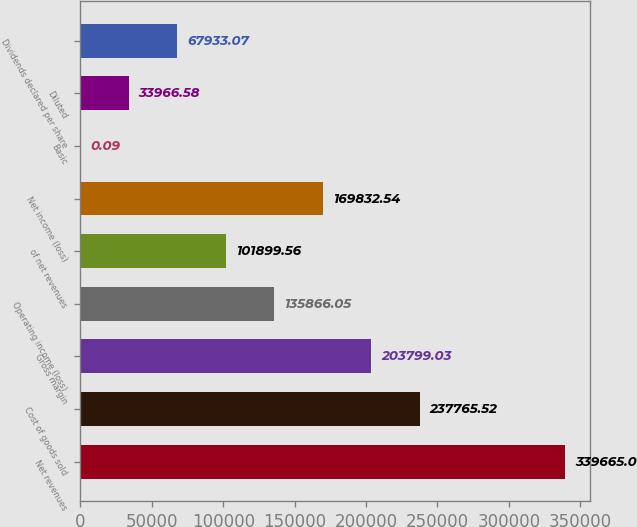Convert chart to OTSL. <chart><loc_0><loc_0><loc_500><loc_500><bar_chart><fcel>Net revenues<fcel>Cost of goods sold<fcel>Gross margin<fcel>Operating income (loss)<fcel>of net revenues<fcel>Net income (loss)<fcel>Basic<fcel>Diluted<fcel>Dividends declared per share<nl><fcel>339665<fcel>237766<fcel>203799<fcel>135866<fcel>101900<fcel>169833<fcel>0.09<fcel>33966.6<fcel>67933.1<nl></chart> 